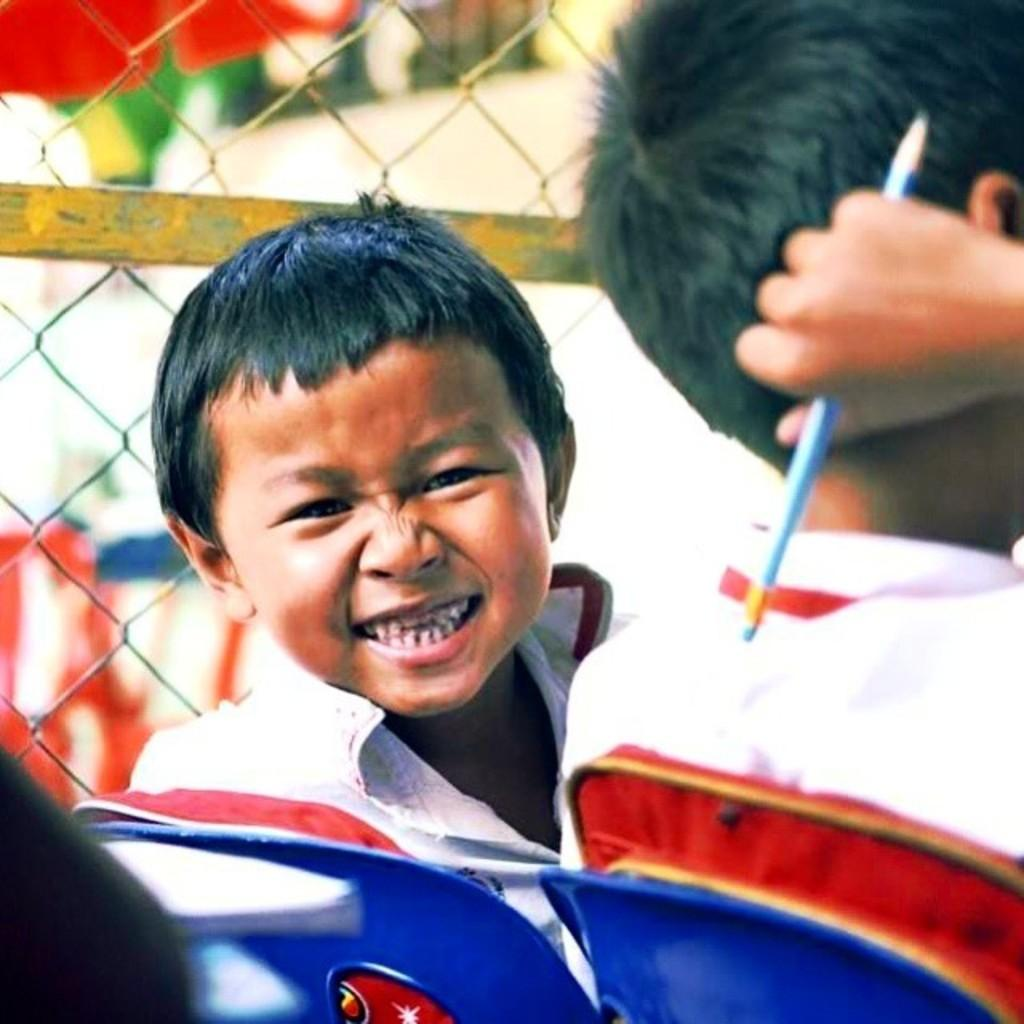How many children are present in the image? There are two children in the image. What are the children doing in the image? The children are sitting on chairs. Can you describe what one of the children is holding? One of the children is holding a pencil. What can be seen in the background of the image? There is a net fencing in the background of the image. What type of meal is being served in the image? There is no meal present in the image; it features two children sitting on chairs with one holding a pencil. 